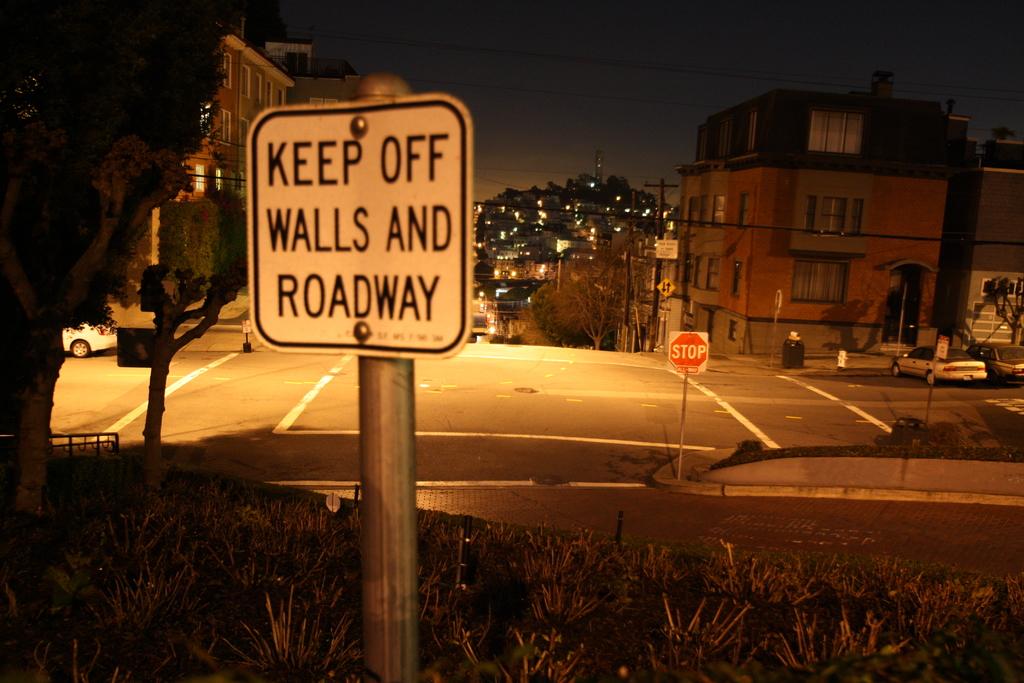Does the sign ask you to stay on or off the walls and roadway?
Your response must be concise. Off. What street sign(s) are visible?
Keep it short and to the point. Keep off walls and roadway. 